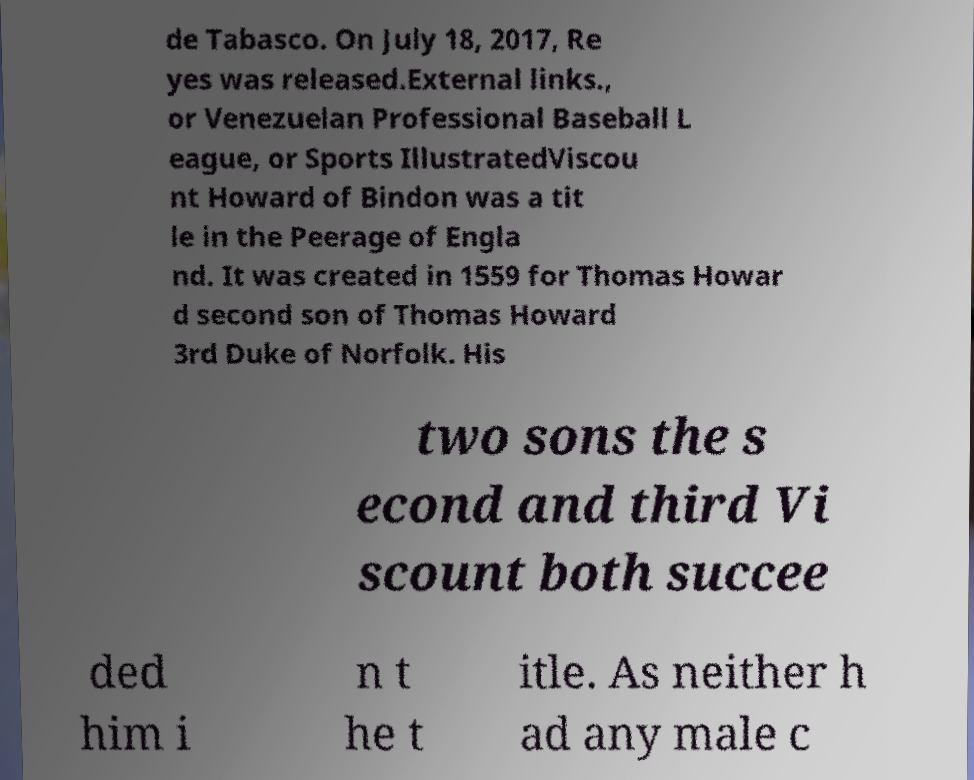Can you read and provide the text displayed in the image?This photo seems to have some interesting text. Can you extract and type it out for me? de Tabasco. On July 18, 2017, Re yes was released.External links., or Venezuelan Professional Baseball L eague, or Sports IllustratedViscou nt Howard of Bindon was a tit le in the Peerage of Engla nd. It was created in 1559 for Thomas Howar d second son of Thomas Howard 3rd Duke of Norfolk. His two sons the s econd and third Vi scount both succee ded him i n t he t itle. As neither h ad any male c 